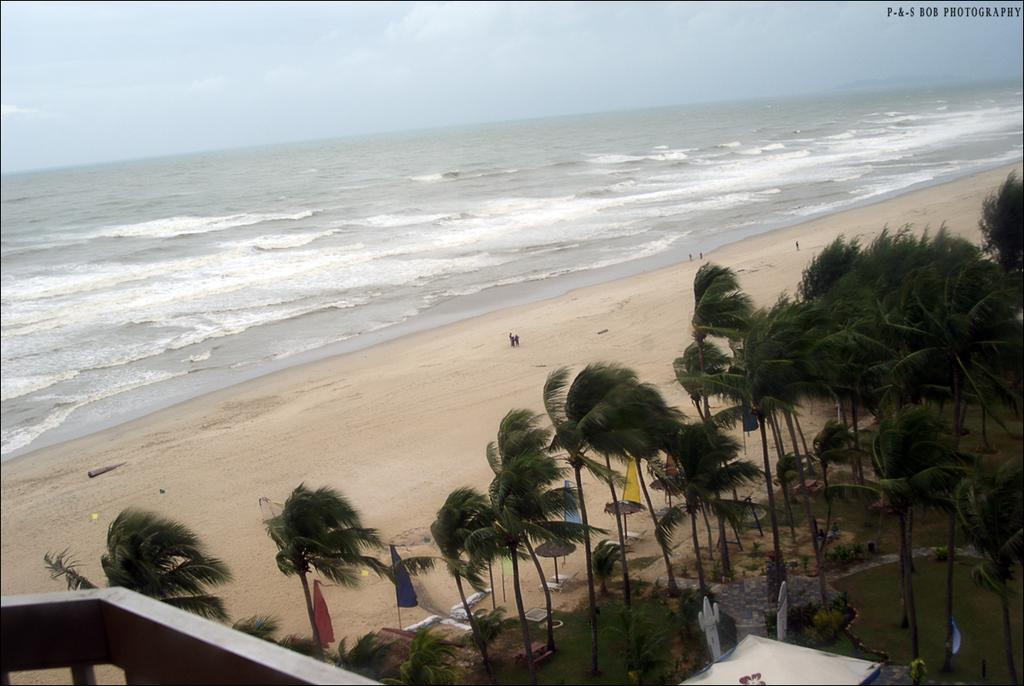What natural feature is present in the image? The image contains the ocean. What are the people in the image doing? The people are standing on the seashore. What type of vegetation can be seen in the image? There are trees and plants in the image. What man-made objects are present in the image? There are sculptures and flags in the image. What part of the sky is visible in the image? The sky is visible in the image. What type of iron is being used to smash the kitty in the image? There is no iron or kitty present in the image, and therefore no such activity can be observed. 